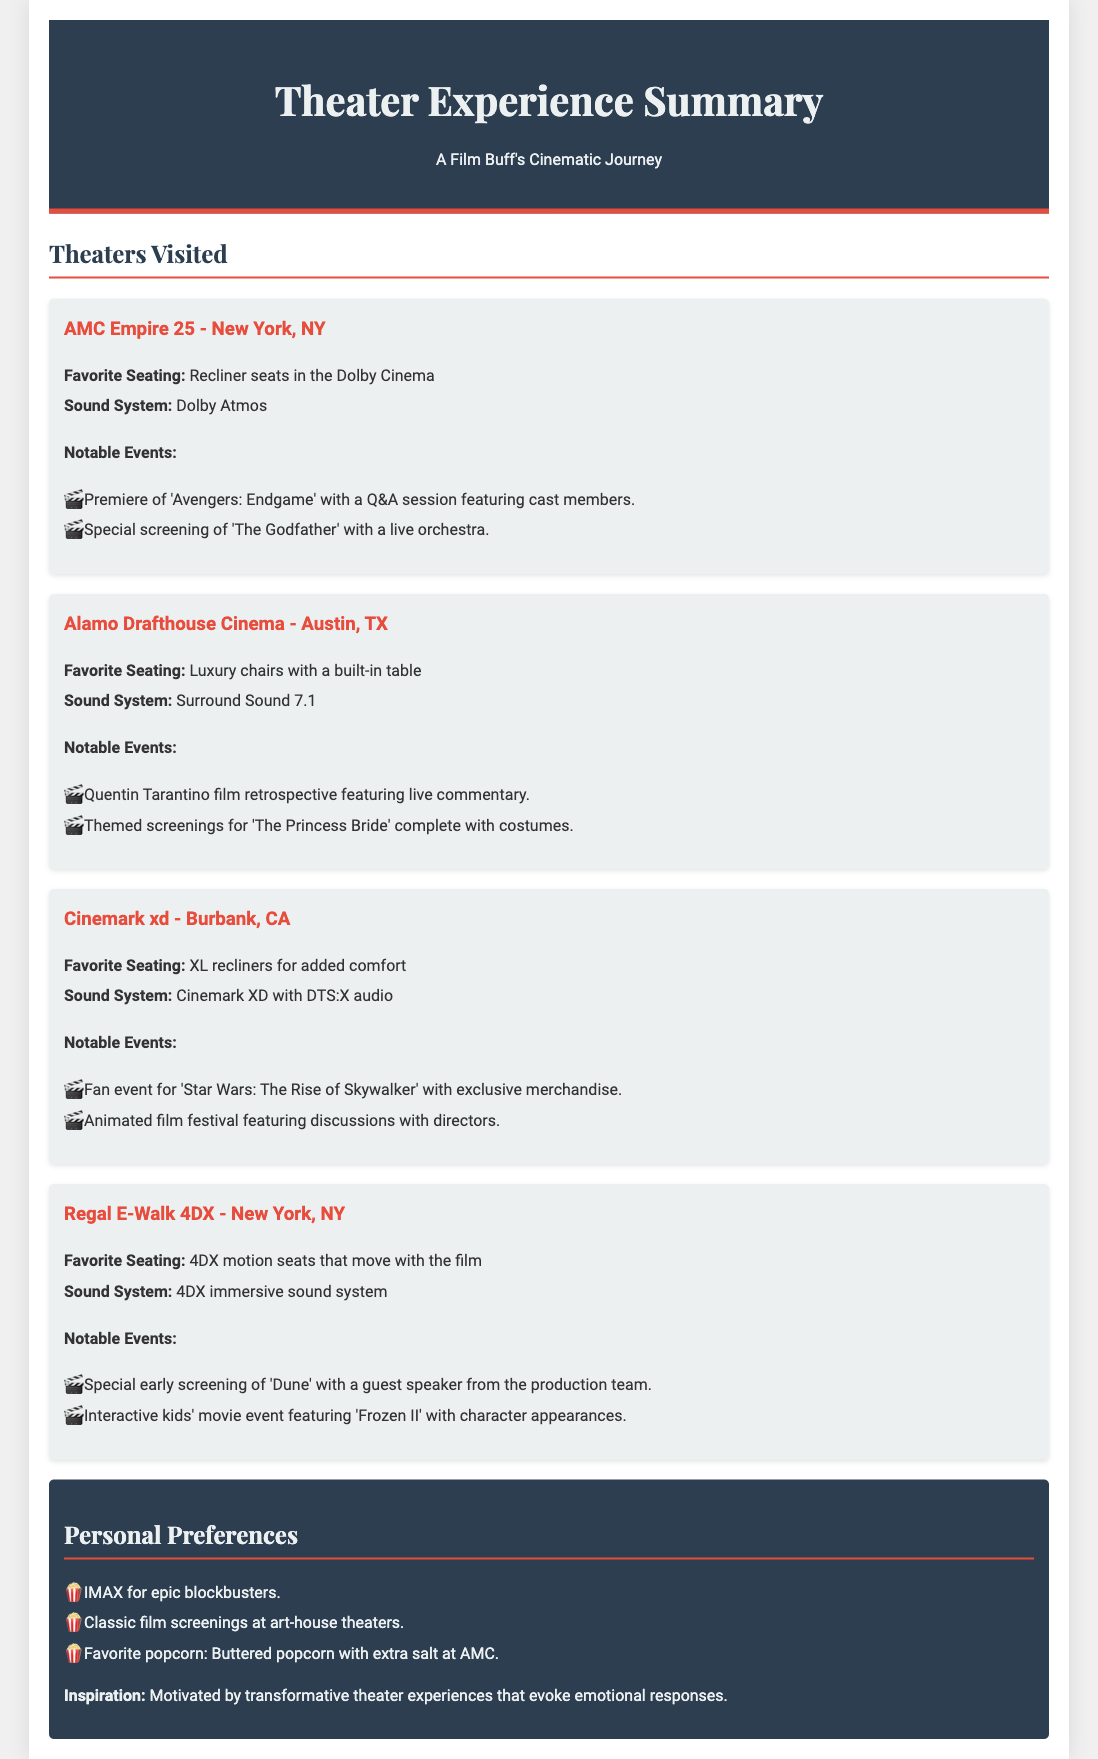What is the favorite seating at AMC Empire 25? The favorite seating at AMC Empire 25 is recliner seats in the Dolby Cinema.
Answer: Recliner seats in the Dolby Cinema What sound system is used at Alamo Drafthouse Cinema? The sound system used at Alamo Drafthouse Cinema is Surround Sound 7.1.
Answer: Surround Sound 7.1 Which notable event was attended at Cinemark xd? A notable event attended at Cinemark xd was a fan event for 'Star Wars: The Rise of Skywalker' with exclusive merchandise.
Answer: Fan event for 'Star Wars: The Rise of Skywalker' What is the favorite popcorn at AMC? The favorite popcorn at AMC is buttered popcorn with extra salt.
Answer: Buttered popcorn with extra salt How many notable events are listed for Regal E-Walk 4DX? There are two notable events listed for Regal E-Walk 4DX.
Answer: Two What is the favorite seating at Alamo Drafthouse Cinema? The favorite seating at Alamo Drafthouse Cinema is luxury chairs with a built-in table.
Answer: Luxury chairs with a built-in table Which theater features 4DX motion seats? The theater that features 4DX motion seats is Regal E-Walk 4DX.
Answer: Regal E-Walk 4DX What kind of screenings does the individual prefer for epic blockbusters? The individual prefers IMAX for epic blockbusters.
Answer: IMAX 